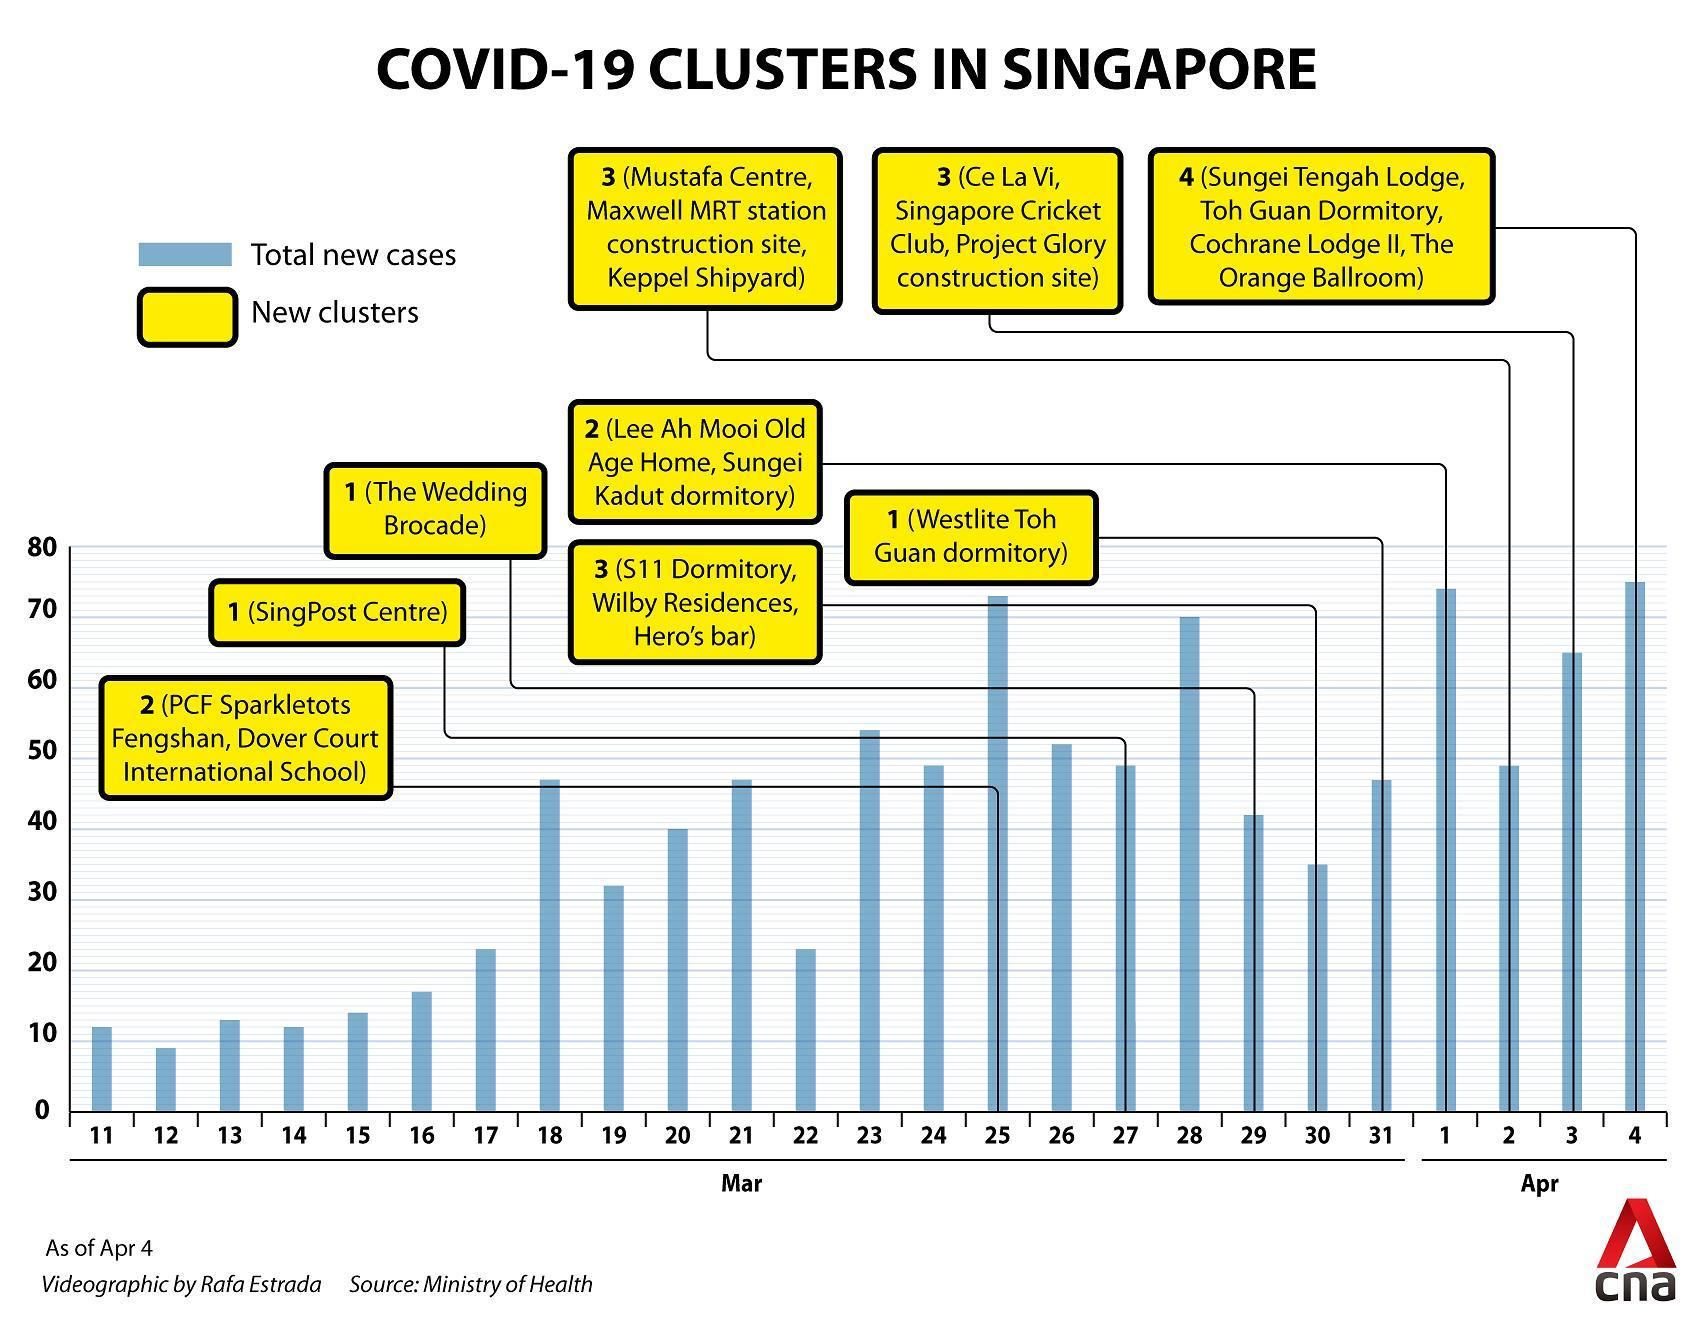How many new cases were declared on March 22?
Answer the question with a short phrase. 23 Which places were marked as COVID-19 clusters on March 25 in Singapore? PCF Sparkletots Fengshan, Dover Court International School Which area was marked as COVID-19 cluster in March 27 in Singapore? SingPost Centre How many new COVID-19 clusters were declared on April 4th in Singapore? 4 On which date in March was The Wedding Brocade declared as a COVID-19 cluster? 29 On which date in April was 65 new cases declared? 3 How many new COVID-19 clusters were declared on April 3rd in Singapore? 3 On how many days the total new cases reported was higher than 70? 3 Which areas were marked as COVID-19 clusters on April 1st in Singapore? Lee Ah Mooi Old Age Home, Sungei Kadut dormitory Which areas were marked as COVID-19 clusters on March 30 in Singapore? S11 Dormitory, Wilby Residences, Hero's bar 